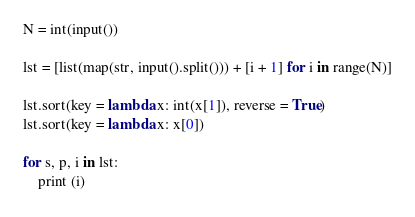Convert code to text. <code><loc_0><loc_0><loc_500><loc_500><_Python_>N = int(input())

lst = [list(map(str, input().split())) + [i + 1] for i in range(N)]

lst.sort(key = lambda x: int(x[1]), reverse = True)
lst.sort(key = lambda x: x[0])

for s, p, i in lst:
    print (i)</code> 